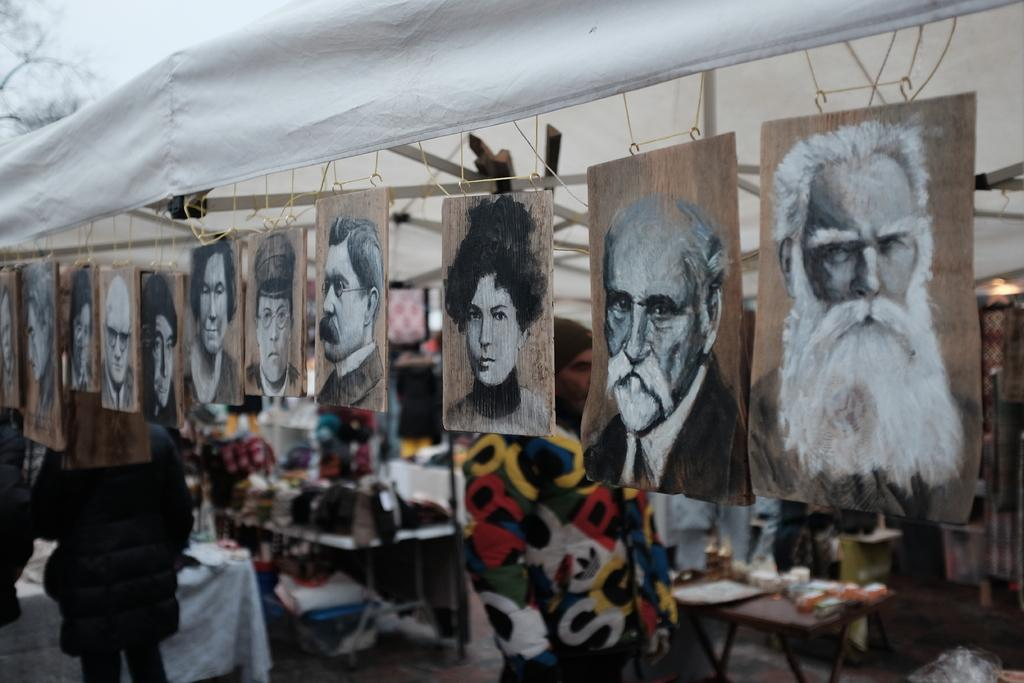Who or what can be seen in the image? There are people in the image. What is covering the tables in the image? There are tablecloths in the image. What is hanging on the walls or displayed in the image? There are pictures in the image. What else can be seen in the image besides people and tablecloths? There are objects in the image. What structure is visible at the top of the image? There is a tent at the top of the image. What type of fork is being used by the people in the image? There is no fork visible in the image; only people, tablecloths, pictures, objects, and a tent are present. 